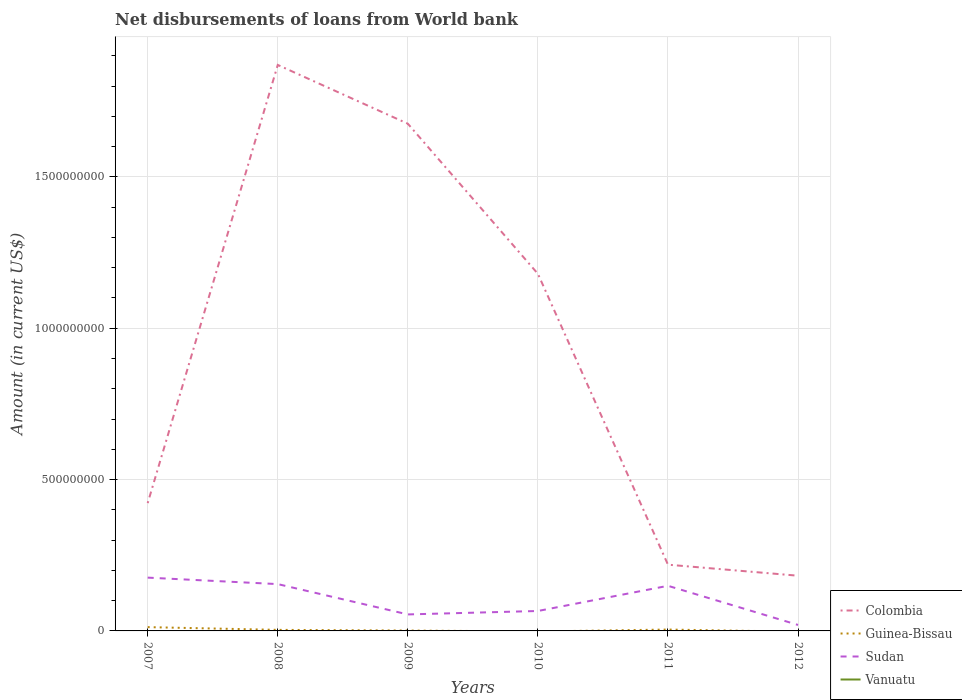Across all years, what is the maximum amount of loan disbursed from World Bank in Colombia?
Your answer should be very brief. 1.82e+08. What is the total amount of loan disbursed from World Bank in Sudan in the graph?
Your answer should be very brief. 1.22e+08. What is the difference between the highest and the second highest amount of loan disbursed from World Bank in Colombia?
Your answer should be compact. 1.69e+09. How many lines are there?
Provide a short and direct response. 3. What is the title of the graph?
Your response must be concise. Net disbursements of loans from World bank. Does "Iran" appear as one of the legend labels in the graph?
Your response must be concise. No. What is the label or title of the X-axis?
Keep it short and to the point. Years. What is the label or title of the Y-axis?
Provide a short and direct response. Amount (in current US$). What is the Amount (in current US$) in Colombia in 2007?
Keep it short and to the point. 4.22e+08. What is the Amount (in current US$) in Guinea-Bissau in 2007?
Offer a terse response. 1.25e+07. What is the Amount (in current US$) of Sudan in 2007?
Provide a succinct answer. 1.76e+08. What is the Amount (in current US$) in Colombia in 2008?
Offer a very short reply. 1.87e+09. What is the Amount (in current US$) of Guinea-Bissau in 2008?
Your answer should be very brief. 3.49e+06. What is the Amount (in current US$) of Sudan in 2008?
Your answer should be very brief. 1.55e+08. What is the Amount (in current US$) in Colombia in 2009?
Your answer should be compact. 1.68e+09. What is the Amount (in current US$) in Guinea-Bissau in 2009?
Your answer should be very brief. 1.27e+06. What is the Amount (in current US$) of Sudan in 2009?
Keep it short and to the point. 5.45e+07. What is the Amount (in current US$) of Colombia in 2010?
Your answer should be compact. 1.18e+09. What is the Amount (in current US$) of Guinea-Bissau in 2010?
Your response must be concise. 0. What is the Amount (in current US$) of Sudan in 2010?
Keep it short and to the point. 6.59e+07. What is the Amount (in current US$) in Vanuatu in 2010?
Provide a succinct answer. 0. What is the Amount (in current US$) in Colombia in 2011?
Provide a succinct answer. 2.19e+08. What is the Amount (in current US$) of Guinea-Bissau in 2011?
Give a very brief answer. 4.56e+06. What is the Amount (in current US$) of Sudan in 2011?
Ensure brevity in your answer.  1.49e+08. What is the Amount (in current US$) of Vanuatu in 2011?
Make the answer very short. 0. What is the Amount (in current US$) in Colombia in 2012?
Your answer should be compact. 1.82e+08. What is the Amount (in current US$) of Sudan in 2012?
Offer a terse response. 1.97e+07. What is the Amount (in current US$) in Vanuatu in 2012?
Make the answer very short. 0. Across all years, what is the maximum Amount (in current US$) in Colombia?
Provide a short and direct response. 1.87e+09. Across all years, what is the maximum Amount (in current US$) in Guinea-Bissau?
Give a very brief answer. 1.25e+07. Across all years, what is the maximum Amount (in current US$) of Sudan?
Make the answer very short. 1.76e+08. Across all years, what is the minimum Amount (in current US$) of Colombia?
Make the answer very short. 1.82e+08. Across all years, what is the minimum Amount (in current US$) in Guinea-Bissau?
Offer a terse response. 0. Across all years, what is the minimum Amount (in current US$) in Sudan?
Offer a terse response. 1.97e+07. What is the total Amount (in current US$) of Colombia in the graph?
Offer a very short reply. 5.55e+09. What is the total Amount (in current US$) of Guinea-Bissau in the graph?
Keep it short and to the point. 2.18e+07. What is the total Amount (in current US$) in Sudan in the graph?
Your response must be concise. 6.20e+08. What is the difference between the Amount (in current US$) in Colombia in 2007 and that in 2008?
Your answer should be very brief. -1.45e+09. What is the difference between the Amount (in current US$) in Guinea-Bissau in 2007 and that in 2008?
Your answer should be very brief. 9.02e+06. What is the difference between the Amount (in current US$) in Sudan in 2007 and that in 2008?
Ensure brevity in your answer.  2.14e+07. What is the difference between the Amount (in current US$) in Colombia in 2007 and that in 2009?
Your response must be concise. -1.25e+09. What is the difference between the Amount (in current US$) of Guinea-Bissau in 2007 and that in 2009?
Make the answer very short. 1.12e+07. What is the difference between the Amount (in current US$) in Sudan in 2007 and that in 2009?
Your answer should be compact. 1.22e+08. What is the difference between the Amount (in current US$) in Colombia in 2007 and that in 2010?
Provide a short and direct response. -7.58e+08. What is the difference between the Amount (in current US$) of Sudan in 2007 and that in 2010?
Provide a short and direct response. 1.10e+08. What is the difference between the Amount (in current US$) of Colombia in 2007 and that in 2011?
Ensure brevity in your answer.  2.03e+08. What is the difference between the Amount (in current US$) in Guinea-Bissau in 2007 and that in 2011?
Your answer should be compact. 7.96e+06. What is the difference between the Amount (in current US$) of Sudan in 2007 and that in 2011?
Offer a very short reply. 2.70e+07. What is the difference between the Amount (in current US$) of Colombia in 2007 and that in 2012?
Offer a terse response. 2.40e+08. What is the difference between the Amount (in current US$) in Sudan in 2007 and that in 2012?
Provide a short and direct response. 1.56e+08. What is the difference between the Amount (in current US$) in Colombia in 2008 and that in 2009?
Provide a succinct answer. 1.94e+08. What is the difference between the Amount (in current US$) in Guinea-Bissau in 2008 and that in 2009?
Give a very brief answer. 2.22e+06. What is the difference between the Amount (in current US$) in Sudan in 2008 and that in 2009?
Give a very brief answer. 1.00e+08. What is the difference between the Amount (in current US$) of Colombia in 2008 and that in 2010?
Offer a terse response. 6.90e+08. What is the difference between the Amount (in current US$) of Sudan in 2008 and that in 2010?
Your answer should be very brief. 8.88e+07. What is the difference between the Amount (in current US$) of Colombia in 2008 and that in 2011?
Offer a terse response. 1.65e+09. What is the difference between the Amount (in current US$) of Guinea-Bissau in 2008 and that in 2011?
Your answer should be very brief. -1.06e+06. What is the difference between the Amount (in current US$) of Sudan in 2008 and that in 2011?
Provide a short and direct response. 5.61e+06. What is the difference between the Amount (in current US$) in Colombia in 2008 and that in 2012?
Provide a short and direct response. 1.69e+09. What is the difference between the Amount (in current US$) in Sudan in 2008 and that in 2012?
Give a very brief answer. 1.35e+08. What is the difference between the Amount (in current US$) in Colombia in 2009 and that in 2010?
Give a very brief answer. 4.96e+08. What is the difference between the Amount (in current US$) in Sudan in 2009 and that in 2010?
Make the answer very short. -1.14e+07. What is the difference between the Amount (in current US$) of Colombia in 2009 and that in 2011?
Keep it short and to the point. 1.46e+09. What is the difference between the Amount (in current US$) of Guinea-Bissau in 2009 and that in 2011?
Keep it short and to the point. -3.29e+06. What is the difference between the Amount (in current US$) in Sudan in 2009 and that in 2011?
Make the answer very short. -9.45e+07. What is the difference between the Amount (in current US$) of Colombia in 2009 and that in 2012?
Your response must be concise. 1.49e+09. What is the difference between the Amount (in current US$) in Sudan in 2009 and that in 2012?
Ensure brevity in your answer.  3.48e+07. What is the difference between the Amount (in current US$) of Colombia in 2010 and that in 2011?
Provide a succinct answer. 9.61e+08. What is the difference between the Amount (in current US$) in Sudan in 2010 and that in 2011?
Offer a terse response. -8.32e+07. What is the difference between the Amount (in current US$) of Colombia in 2010 and that in 2012?
Make the answer very short. 9.97e+08. What is the difference between the Amount (in current US$) of Sudan in 2010 and that in 2012?
Give a very brief answer. 4.61e+07. What is the difference between the Amount (in current US$) in Colombia in 2011 and that in 2012?
Ensure brevity in your answer.  3.64e+07. What is the difference between the Amount (in current US$) of Sudan in 2011 and that in 2012?
Offer a terse response. 1.29e+08. What is the difference between the Amount (in current US$) in Colombia in 2007 and the Amount (in current US$) in Guinea-Bissau in 2008?
Your answer should be very brief. 4.19e+08. What is the difference between the Amount (in current US$) in Colombia in 2007 and the Amount (in current US$) in Sudan in 2008?
Provide a short and direct response. 2.68e+08. What is the difference between the Amount (in current US$) of Guinea-Bissau in 2007 and the Amount (in current US$) of Sudan in 2008?
Make the answer very short. -1.42e+08. What is the difference between the Amount (in current US$) in Colombia in 2007 and the Amount (in current US$) in Guinea-Bissau in 2009?
Give a very brief answer. 4.21e+08. What is the difference between the Amount (in current US$) of Colombia in 2007 and the Amount (in current US$) of Sudan in 2009?
Provide a succinct answer. 3.68e+08. What is the difference between the Amount (in current US$) of Guinea-Bissau in 2007 and the Amount (in current US$) of Sudan in 2009?
Ensure brevity in your answer.  -4.20e+07. What is the difference between the Amount (in current US$) in Colombia in 2007 and the Amount (in current US$) in Sudan in 2010?
Ensure brevity in your answer.  3.56e+08. What is the difference between the Amount (in current US$) in Guinea-Bissau in 2007 and the Amount (in current US$) in Sudan in 2010?
Your response must be concise. -5.33e+07. What is the difference between the Amount (in current US$) in Colombia in 2007 and the Amount (in current US$) in Guinea-Bissau in 2011?
Your response must be concise. 4.18e+08. What is the difference between the Amount (in current US$) in Colombia in 2007 and the Amount (in current US$) in Sudan in 2011?
Make the answer very short. 2.73e+08. What is the difference between the Amount (in current US$) in Guinea-Bissau in 2007 and the Amount (in current US$) in Sudan in 2011?
Provide a short and direct response. -1.37e+08. What is the difference between the Amount (in current US$) in Colombia in 2007 and the Amount (in current US$) in Sudan in 2012?
Your answer should be very brief. 4.02e+08. What is the difference between the Amount (in current US$) of Guinea-Bissau in 2007 and the Amount (in current US$) of Sudan in 2012?
Offer a very short reply. -7.22e+06. What is the difference between the Amount (in current US$) in Colombia in 2008 and the Amount (in current US$) in Guinea-Bissau in 2009?
Your answer should be compact. 1.87e+09. What is the difference between the Amount (in current US$) of Colombia in 2008 and the Amount (in current US$) of Sudan in 2009?
Provide a succinct answer. 1.82e+09. What is the difference between the Amount (in current US$) in Guinea-Bissau in 2008 and the Amount (in current US$) in Sudan in 2009?
Provide a short and direct response. -5.10e+07. What is the difference between the Amount (in current US$) in Colombia in 2008 and the Amount (in current US$) in Sudan in 2010?
Provide a succinct answer. 1.80e+09. What is the difference between the Amount (in current US$) of Guinea-Bissau in 2008 and the Amount (in current US$) of Sudan in 2010?
Your response must be concise. -6.24e+07. What is the difference between the Amount (in current US$) of Colombia in 2008 and the Amount (in current US$) of Guinea-Bissau in 2011?
Make the answer very short. 1.87e+09. What is the difference between the Amount (in current US$) of Colombia in 2008 and the Amount (in current US$) of Sudan in 2011?
Offer a very short reply. 1.72e+09. What is the difference between the Amount (in current US$) in Guinea-Bissau in 2008 and the Amount (in current US$) in Sudan in 2011?
Keep it short and to the point. -1.46e+08. What is the difference between the Amount (in current US$) in Colombia in 2008 and the Amount (in current US$) in Sudan in 2012?
Ensure brevity in your answer.  1.85e+09. What is the difference between the Amount (in current US$) in Guinea-Bissau in 2008 and the Amount (in current US$) in Sudan in 2012?
Offer a very short reply. -1.62e+07. What is the difference between the Amount (in current US$) of Colombia in 2009 and the Amount (in current US$) of Sudan in 2010?
Your response must be concise. 1.61e+09. What is the difference between the Amount (in current US$) of Guinea-Bissau in 2009 and the Amount (in current US$) of Sudan in 2010?
Offer a very short reply. -6.46e+07. What is the difference between the Amount (in current US$) of Colombia in 2009 and the Amount (in current US$) of Guinea-Bissau in 2011?
Keep it short and to the point. 1.67e+09. What is the difference between the Amount (in current US$) in Colombia in 2009 and the Amount (in current US$) in Sudan in 2011?
Offer a terse response. 1.53e+09. What is the difference between the Amount (in current US$) of Guinea-Bissau in 2009 and the Amount (in current US$) of Sudan in 2011?
Keep it short and to the point. -1.48e+08. What is the difference between the Amount (in current US$) of Colombia in 2009 and the Amount (in current US$) of Sudan in 2012?
Give a very brief answer. 1.66e+09. What is the difference between the Amount (in current US$) in Guinea-Bissau in 2009 and the Amount (in current US$) in Sudan in 2012?
Offer a very short reply. -1.85e+07. What is the difference between the Amount (in current US$) of Colombia in 2010 and the Amount (in current US$) of Guinea-Bissau in 2011?
Offer a terse response. 1.18e+09. What is the difference between the Amount (in current US$) of Colombia in 2010 and the Amount (in current US$) of Sudan in 2011?
Provide a succinct answer. 1.03e+09. What is the difference between the Amount (in current US$) in Colombia in 2010 and the Amount (in current US$) in Sudan in 2012?
Make the answer very short. 1.16e+09. What is the difference between the Amount (in current US$) of Colombia in 2011 and the Amount (in current US$) of Sudan in 2012?
Offer a very short reply. 1.99e+08. What is the difference between the Amount (in current US$) of Guinea-Bissau in 2011 and the Amount (in current US$) of Sudan in 2012?
Your response must be concise. -1.52e+07. What is the average Amount (in current US$) of Colombia per year?
Offer a very short reply. 9.25e+08. What is the average Amount (in current US$) of Guinea-Bissau per year?
Ensure brevity in your answer.  3.64e+06. What is the average Amount (in current US$) of Sudan per year?
Provide a succinct answer. 1.03e+08. In the year 2007, what is the difference between the Amount (in current US$) of Colombia and Amount (in current US$) of Guinea-Bissau?
Provide a succinct answer. 4.10e+08. In the year 2007, what is the difference between the Amount (in current US$) of Colombia and Amount (in current US$) of Sudan?
Provide a succinct answer. 2.46e+08. In the year 2007, what is the difference between the Amount (in current US$) in Guinea-Bissau and Amount (in current US$) in Sudan?
Your answer should be very brief. -1.64e+08. In the year 2008, what is the difference between the Amount (in current US$) of Colombia and Amount (in current US$) of Guinea-Bissau?
Ensure brevity in your answer.  1.87e+09. In the year 2008, what is the difference between the Amount (in current US$) in Colombia and Amount (in current US$) in Sudan?
Offer a very short reply. 1.72e+09. In the year 2008, what is the difference between the Amount (in current US$) in Guinea-Bissau and Amount (in current US$) in Sudan?
Your answer should be compact. -1.51e+08. In the year 2009, what is the difference between the Amount (in current US$) in Colombia and Amount (in current US$) in Guinea-Bissau?
Keep it short and to the point. 1.67e+09. In the year 2009, what is the difference between the Amount (in current US$) in Colombia and Amount (in current US$) in Sudan?
Offer a very short reply. 1.62e+09. In the year 2009, what is the difference between the Amount (in current US$) of Guinea-Bissau and Amount (in current US$) of Sudan?
Provide a succinct answer. -5.32e+07. In the year 2010, what is the difference between the Amount (in current US$) of Colombia and Amount (in current US$) of Sudan?
Make the answer very short. 1.11e+09. In the year 2011, what is the difference between the Amount (in current US$) of Colombia and Amount (in current US$) of Guinea-Bissau?
Offer a terse response. 2.14e+08. In the year 2011, what is the difference between the Amount (in current US$) in Colombia and Amount (in current US$) in Sudan?
Your answer should be very brief. 6.98e+07. In the year 2011, what is the difference between the Amount (in current US$) of Guinea-Bissau and Amount (in current US$) of Sudan?
Your answer should be compact. -1.44e+08. In the year 2012, what is the difference between the Amount (in current US$) of Colombia and Amount (in current US$) of Sudan?
Your answer should be compact. 1.63e+08. What is the ratio of the Amount (in current US$) in Colombia in 2007 to that in 2008?
Provide a succinct answer. 0.23. What is the ratio of the Amount (in current US$) in Guinea-Bissau in 2007 to that in 2008?
Keep it short and to the point. 3.59. What is the ratio of the Amount (in current US$) of Sudan in 2007 to that in 2008?
Offer a terse response. 1.14. What is the ratio of the Amount (in current US$) of Colombia in 2007 to that in 2009?
Provide a succinct answer. 0.25. What is the ratio of the Amount (in current US$) in Guinea-Bissau in 2007 to that in 2009?
Offer a very short reply. 9.86. What is the ratio of the Amount (in current US$) of Sudan in 2007 to that in 2009?
Ensure brevity in your answer.  3.23. What is the ratio of the Amount (in current US$) in Colombia in 2007 to that in 2010?
Your answer should be very brief. 0.36. What is the ratio of the Amount (in current US$) of Sudan in 2007 to that in 2010?
Provide a succinct answer. 2.67. What is the ratio of the Amount (in current US$) of Colombia in 2007 to that in 2011?
Provide a succinct answer. 1.93. What is the ratio of the Amount (in current US$) in Guinea-Bissau in 2007 to that in 2011?
Your answer should be compact. 2.75. What is the ratio of the Amount (in current US$) in Sudan in 2007 to that in 2011?
Provide a succinct answer. 1.18. What is the ratio of the Amount (in current US$) in Colombia in 2007 to that in 2012?
Give a very brief answer. 2.32. What is the ratio of the Amount (in current US$) in Sudan in 2007 to that in 2012?
Ensure brevity in your answer.  8.92. What is the ratio of the Amount (in current US$) in Colombia in 2008 to that in 2009?
Your answer should be compact. 1.12. What is the ratio of the Amount (in current US$) in Guinea-Bissau in 2008 to that in 2009?
Provide a succinct answer. 2.75. What is the ratio of the Amount (in current US$) of Sudan in 2008 to that in 2009?
Your answer should be very brief. 2.84. What is the ratio of the Amount (in current US$) of Colombia in 2008 to that in 2010?
Provide a succinct answer. 1.58. What is the ratio of the Amount (in current US$) of Sudan in 2008 to that in 2010?
Your response must be concise. 2.35. What is the ratio of the Amount (in current US$) of Colombia in 2008 to that in 2011?
Offer a very short reply. 8.54. What is the ratio of the Amount (in current US$) in Guinea-Bissau in 2008 to that in 2011?
Give a very brief answer. 0.77. What is the ratio of the Amount (in current US$) of Sudan in 2008 to that in 2011?
Your answer should be very brief. 1.04. What is the ratio of the Amount (in current US$) in Colombia in 2008 to that in 2012?
Offer a very short reply. 10.25. What is the ratio of the Amount (in current US$) in Sudan in 2008 to that in 2012?
Offer a very short reply. 7.84. What is the ratio of the Amount (in current US$) in Colombia in 2009 to that in 2010?
Offer a very short reply. 1.42. What is the ratio of the Amount (in current US$) in Sudan in 2009 to that in 2010?
Offer a very short reply. 0.83. What is the ratio of the Amount (in current US$) in Colombia in 2009 to that in 2011?
Your answer should be compact. 7.66. What is the ratio of the Amount (in current US$) of Guinea-Bissau in 2009 to that in 2011?
Ensure brevity in your answer.  0.28. What is the ratio of the Amount (in current US$) in Sudan in 2009 to that in 2011?
Ensure brevity in your answer.  0.37. What is the ratio of the Amount (in current US$) in Colombia in 2009 to that in 2012?
Offer a very short reply. 9.19. What is the ratio of the Amount (in current US$) in Sudan in 2009 to that in 2012?
Offer a very short reply. 2.76. What is the ratio of the Amount (in current US$) in Colombia in 2010 to that in 2011?
Provide a succinct answer. 5.39. What is the ratio of the Amount (in current US$) of Sudan in 2010 to that in 2011?
Ensure brevity in your answer.  0.44. What is the ratio of the Amount (in current US$) of Colombia in 2010 to that in 2012?
Provide a succinct answer. 6.47. What is the ratio of the Amount (in current US$) in Sudan in 2010 to that in 2012?
Make the answer very short. 3.34. What is the ratio of the Amount (in current US$) in Colombia in 2011 to that in 2012?
Your answer should be very brief. 1.2. What is the ratio of the Amount (in current US$) of Sudan in 2011 to that in 2012?
Offer a terse response. 7.55. What is the difference between the highest and the second highest Amount (in current US$) of Colombia?
Give a very brief answer. 1.94e+08. What is the difference between the highest and the second highest Amount (in current US$) of Guinea-Bissau?
Offer a terse response. 7.96e+06. What is the difference between the highest and the second highest Amount (in current US$) in Sudan?
Your answer should be compact. 2.14e+07. What is the difference between the highest and the lowest Amount (in current US$) in Colombia?
Your answer should be very brief. 1.69e+09. What is the difference between the highest and the lowest Amount (in current US$) of Guinea-Bissau?
Make the answer very short. 1.25e+07. What is the difference between the highest and the lowest Amount (in current US$) in Sudan?
Offer a terse response. 1.56e+08. 